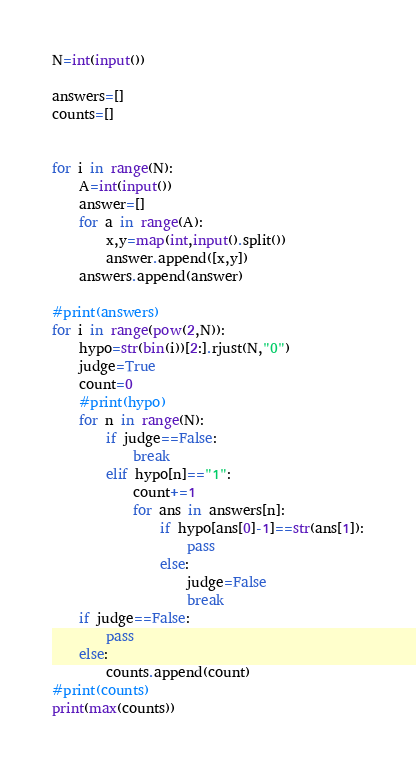<code> <loc_0><loc_0><loc_500><loc_500><_Python_>N=int(input())

answers=[]
counts=[]


for i in range(N):
    A=int(input())
    answer=[]
    for a in range(A):
        x,y=map(int,input().split())
        answer.append([x,y])
    answers.append(answer)

#print(answers)
for i in range(pow(2,N)):
    hypo=str(bin(i))[2:].rjust(N,"0")
    judge=True
    count=0
    #print(hypo)
    for n in range(N):
        if judge==False:
            break
        elif hypo[n]=="1":
            count+=1
            for ans in answers[n]:
                if hypo[ans[0]-1]==str(ans[1]):
                    pass
                else:
                    judge=False
                    break
    if judge==False:
        pass
    else:
        counts.append(count)
#print(counts)
print(max(counts))</code> 